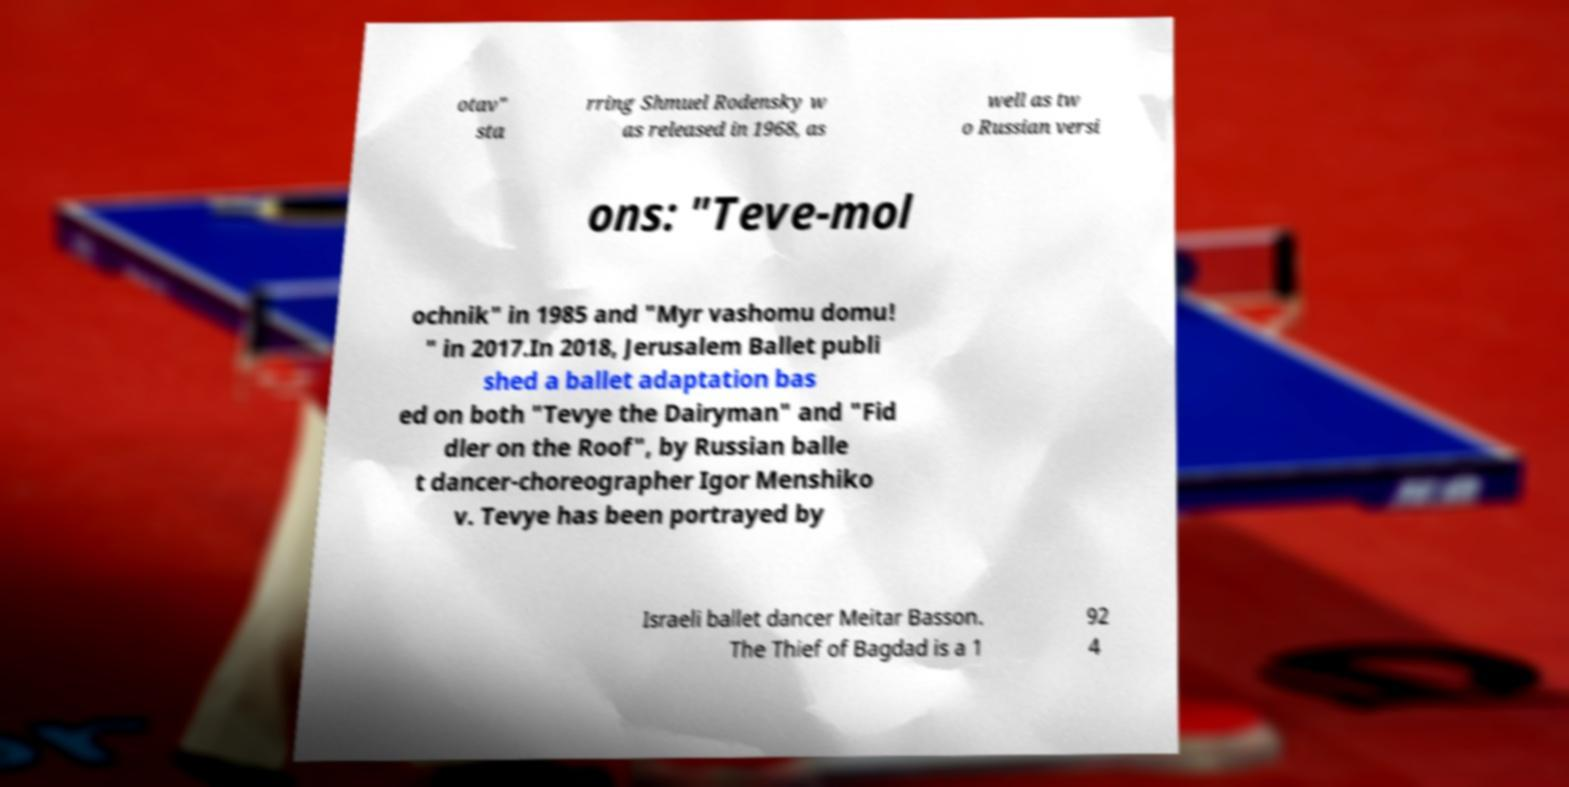Could you extract and type out the text from this image? otav" sta rring Shmuel Rodensky w as released in 1968, as well as tw o Russian versi ons: "Teve-mol ochnik" in 1985 and "Myr vashomu domu! " in 2017.In 2018, Jerusalem Ballet publi shed a ballet adaptation bas ed on both "Tevye the Dairyman" and "Fid dler on the Roof", by Russian balle t dancer-choreographer Igor Menshiko v. Tevye has been portrayed by Israeli ballet dancer Meitar Basson. The Thief of Bagdad is a 1 92 4 